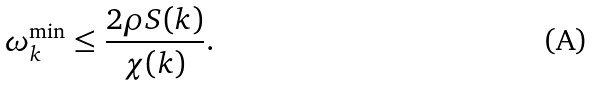<formula> <loc_0><loc_0><loc_500><loc_500>\omega _ { k } ^ { \min } \leq \frac { 2 \rho S ( k ) } { \chi ( k ) } .</formula> 